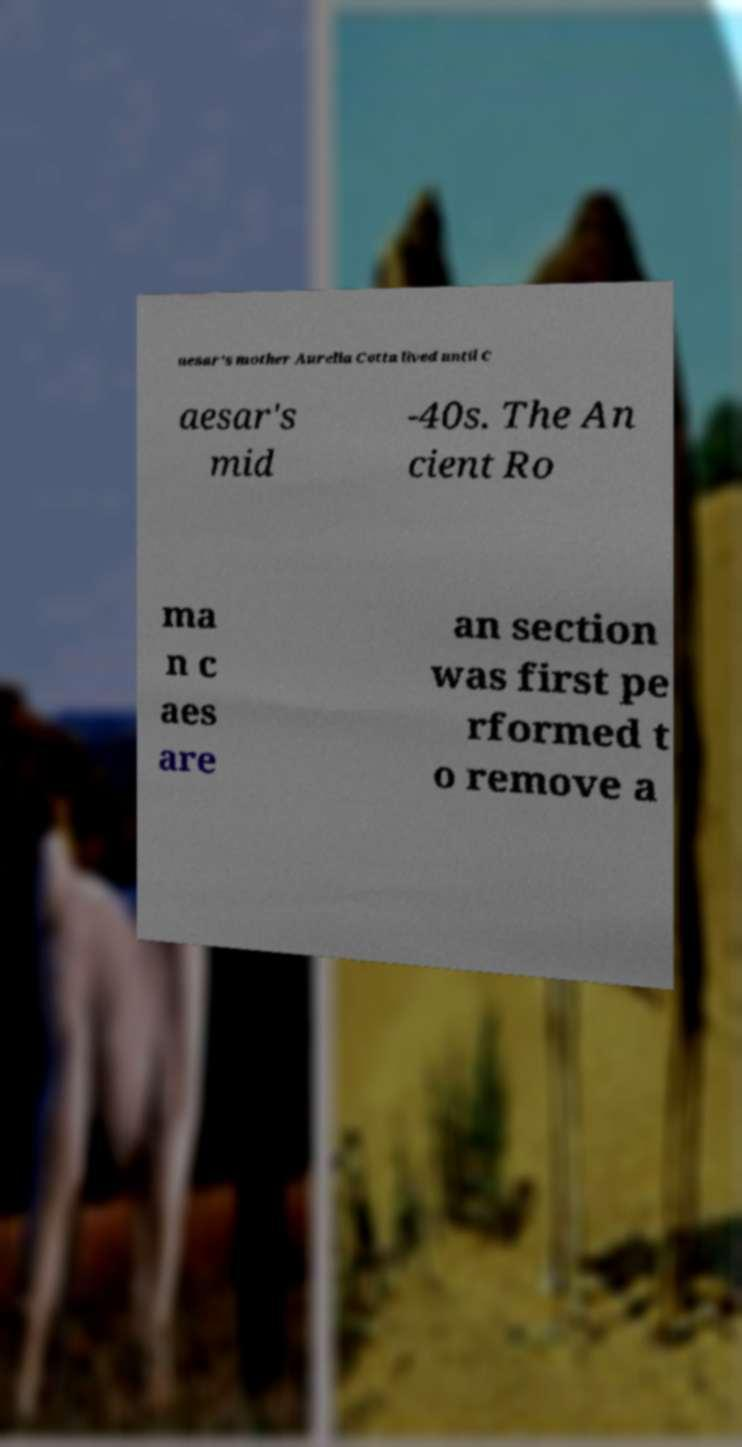Please identify and transcribe the text found in this image. aesar's mother Aurelia Cotta lived until C aesar's mid -40s. The An cient Ro ma n c aes are an section was first pe rformed t o remove a 